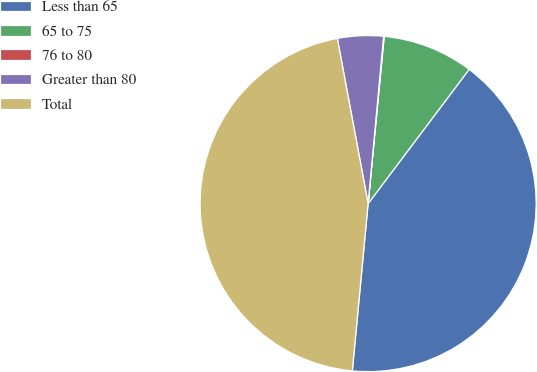Convert chart. <chart><loc_0><loc_0><loc_500><loc_500><pie_chart><fcel>Less than 65<fcel>65 to 75<fcel>76 to 80<fcel>Greater than 80<fcel>Total<nl><fcel>41.23%<fcel>8.74%<fcel>0.06%<fcel>4.4%<fcel>45.57%<nl></chart> 